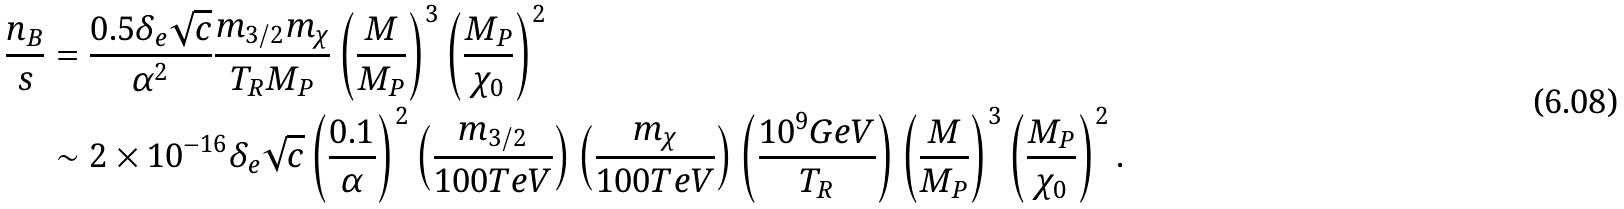<formula> <loc_0><loc_0><loc_500><loc_500>\frac { n _ { B } } { s } & = \frac { 0 . 5 \delta _ { e } \sqrt { c } } { \alpha ^ { 2 } } \frac { m _ { 3 / 2 } m _ { \chi } } { T _ { R } M _ { P } } \left ( \frac { M } { M _ { P } } \right ) ^ { 3 } \left ( \frac { M _ { P } } { \chi _ { 0 } } \right ) ^ { 2 } \\ & \sim 2 \times 1 0 ^ { - 1 6 } \delta _ { e } \sqrt { c } \left ( \frac { 0 . 1 } { \alpha } \right ) ^ { 2 } \left ( \frac { m _ { 3 / 2 } } { 1 0 0 T e V } \right ) \left ( \frac { m _ { \chi } } { 1 0 0 T e V } \right ) \left ( \frac { 1 0 ^ { 9 } G e V } { T _ { R } } \right ) \left ( \frac { M } { M _ { P } } \right ) ^ { 3 } \left ( \frac { M _ { P } } { \chi _ { 0 } } \right ) ^ { 2 } .</formula> 